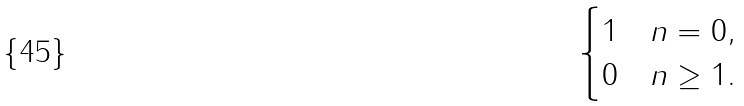<formula> <loc_0><loc_0><loc_500><loc_500>\begin{cases} 1 & n = 0 , \\ 0 & n \geq 1 . \end{cases}</formula> 